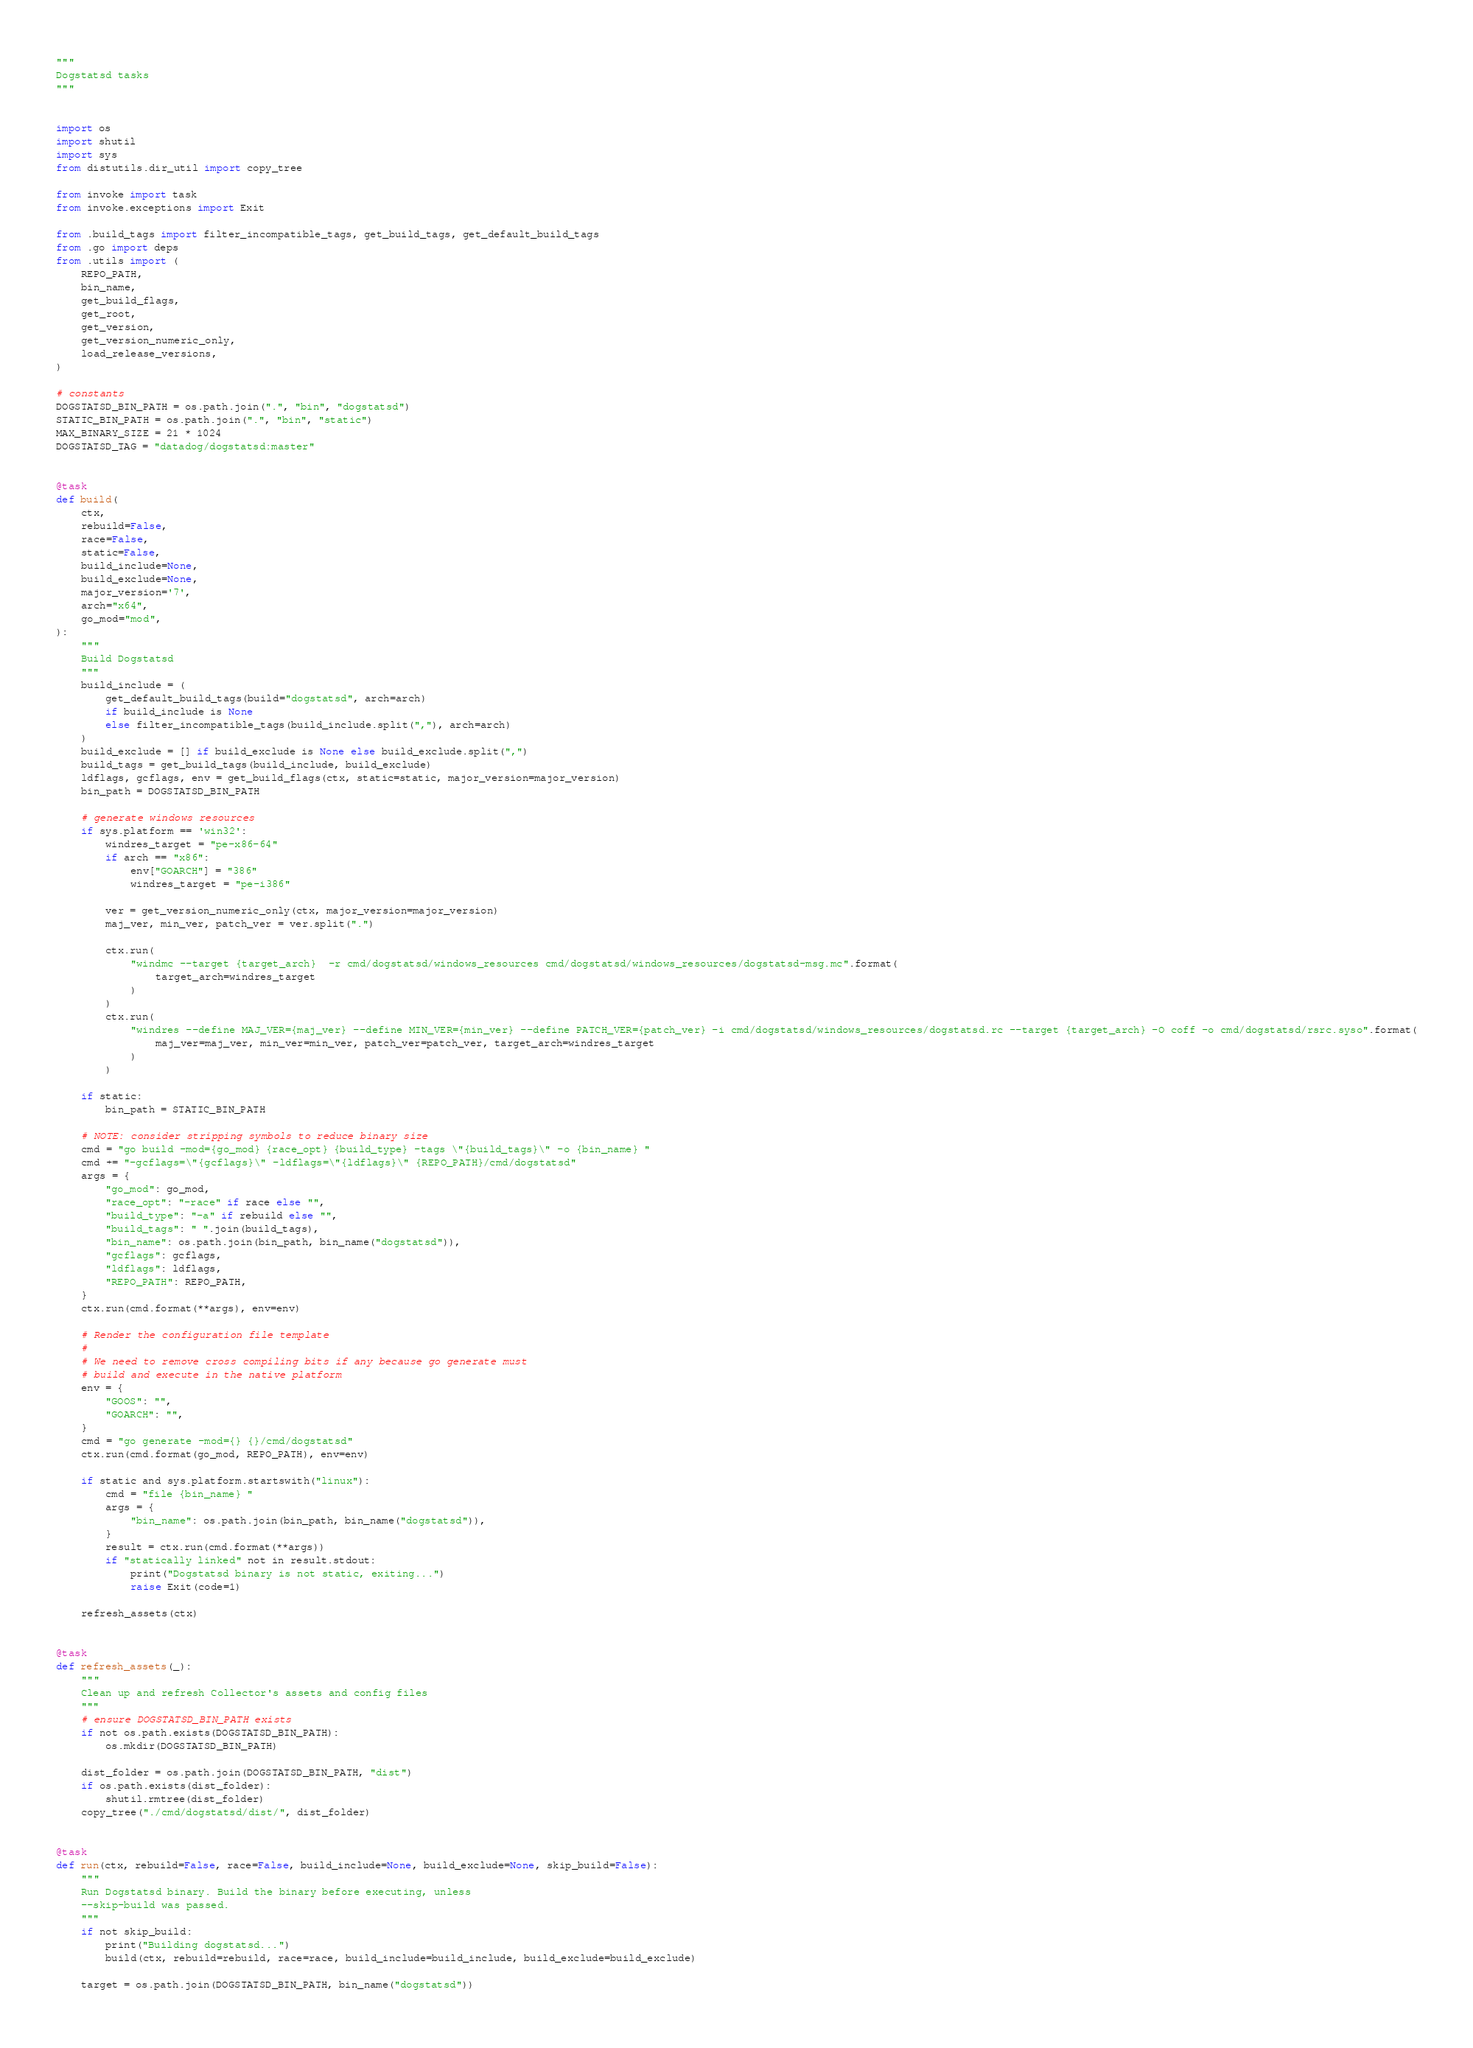<code> <loc_0><loc_0><loc_500><loc_500><_Python_>"""
Dogstatsd tasks
"""


import os
import shutil
import sys
from distutils.dir_util import copy_tree

from invoke import task
from invoke.exceptions import Exit

from .build_tags import filter_incompatible_tags, get_build_tags, get_default_build_tags
from .go import deps
from .utils import (
    REPO_PATH,
    bin_name,
    get_build_flags,
    get_root,
    get_version,
    get_version_numeric_only,
    load_release_versions,
)

# constants
DOGSTATSD_BIN_PATH = os.path.join(".", "bin", "dogstatsd")
STATIC_BIN_PATH = os.path.join(".", "bin", "static")
MAX_BINARY_SIZE = 21 * 1024
DOGSTATSD_TAG = "datadog/dogstatsd:master"


@task
def build(
    ctx,
    rebuild=False,
    race=False,
    static=False,
    build_include=None,
    build_exclude=None,
    major_version='7',
    arch="x64",
    go_mod="mod",
):
    """
    Build Dogstatsd
    """
    build_include = (
        get_default_build_tags(build="dogstatsd", arch=arch)
        if build_include is None
        else filter_incompatible_tags(build_include.split(","), arch=arch)
    )
    build_exclude = [] if build_exclude is None else build_exclude.split(",")
    build_tags = get_build_tags(build_include, build_exclude)
    ldflags, gcflags, env = get_build_flags(ctx, static=static, major_version=major_version)
    bin_path = DOGSTATSD_BIN_PATH

    # generate windows resources
    if sys.platform == 'win32':
        windres_target = "pe-x86-64"
        if arch == "x86":
            env["GOARCH"] = "386"
            windres_target = "pe-i386"

        ver = get_version_numeric_only(ctx, major_version=major_version)
        maj_ver, min_ver, patch_ver = ver.split(".")

        ctx.run(
            "windmc --target {target_arch}  -r cmd/dogstatsd/windows_resources cmd/dogstatsd/windows_resources/dogstatsd-msg.mc".format(
                target_arch=windres_target
            )
        )
        ctx.run(
            "windres --define MAJ_VER={maj_ver} --define MIN_VER={min_ver} --define PATCH_VER={patch_ver} -i cmd/dogstatsd/windows_resources/dogstatsd.rc --target {target_arch} -O coff -o cmd/dogstatsd/rsrc.syso".format(
                maj_ver=maj_ver, min_ver=min_ver, patch_ver=patch_ver, target_arch=windres_target
            )
        )

    if static:
        bin_path = STATIC_BIN_PATH

    # NOTE: consider stripping symbols to reduce binary size
    cmd = "go build -mod={go_mod} {race_opt} {build_type} -tags \"{build_tags}\" -o {bin_name} "
    cmd += "-gcflags=\"{gcflags}\" -ldflags=\"{ldflags}\" {REPO_PATH}/cmd/dogstatsd"
    args = {
        "go_mod": go_mod,
        "race_opt": "-race" if race else "",
        "build_type": "-a" if rebuild else "",
        "build_tags": " ".join(build_tags),
        "bin_name": os.path.join(bin_path, bin_name("dogstatsd")),
        "gcflags": gcflags,
        "ldflags": ldflags,
        "REPO_PATH": REPO_PATH,
    }
    ctx.run(cmd.format(**args), env=env)

    # Render the configuration file template
    #
    # We need to remove cross compiling bits if any because go generate must
    # build and execute in the native platform
    env = {
        "GOOS": "",
        "GOARCH": "",
    }
    cmd = "go generate -mod={} {}/cmd/dogstatsd"
    ctx.run(cmd.format(go_mod, REPO_PATH), env=env)

    if static and sys.platform.startswith("linux"):
        cmd = "file {bin_name} "
        args = {
            "bin_name": os.path.join(bin_path, bin_name("dogstatsd")),
        }
        result = ctx.run(cmd.format(**args))
        if "statically linked" not in result.stdout:
            print("Dogstatsd binary is not static, exiting...")
            raise Exit(code=1)

    refresh_assets(ctx)


@task
def refresh_assets(_):
    """
    Clean up and refresh Collector's assets and config files
    """
    # ensure DOGSTATSD_BIN_PATH exists
    if not os.path.exists(DOGSTATSD_BIN_PATH):
        os.mkdir(DOGSTATSD_BIN_PATH)

    dist_folder = os.path.join(DOGSTATSD_BIN_PATH, "dist")
    if os.path.exists(dist_folder):
        shutil.rmtree(dist_folder)
    copy_tree("./cmd/dogstatsd/dist/", dist_folder)


@task
def run(ctx, rebuild=False, race=False, build_include=None, build_exclude=None, skip_build=False):
    """
    Run Dogstatsd binary. Build the binary before executing, unless
    --skip-build was passed.
    """
    if not skip_build:
        print("Building dogstatsd...")
        build(ctx, rebuild=rebuild, race=race, build_include=build_include, build_exclude=build_exclude)

    target = os.path.join(DOGSTATSD_BIN_PATH, bin_name("dogstatsd"))</code> 